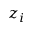Convert formula to latex. <formula><loc_0><loc_0><loc_500><loc_500>z _ { i }</formula> 